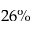<formula> <loc_0><loc_0><loc_500><loc_500>2 6 \%</formula> 